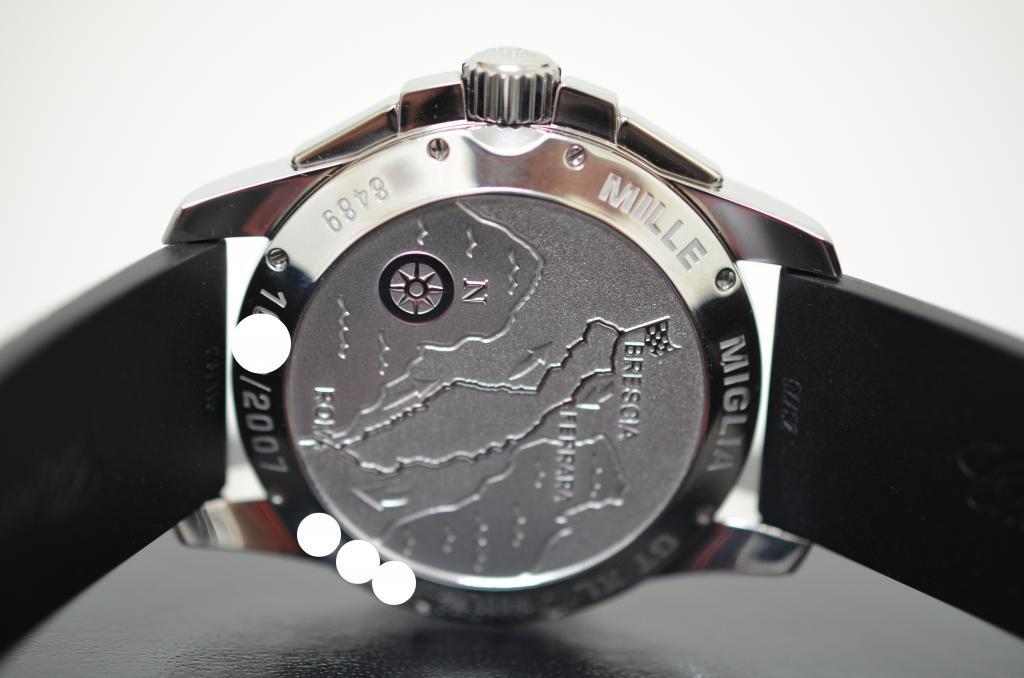What brand is the watch?
Keep it short and to the point. Miglia. What color is the band?
Offer a terse response. Answering does not require reading text in the image. 